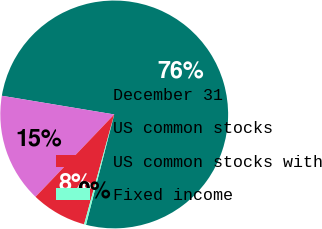Convert chart. <chart><loc_0><loc_0><loc_500><loc_500><pie_chart><fcel>December 31<fcel>US common stocks<fcel>US common stocks with<fcel>Fixed income<nl><fcel>76.37%<fcel>15.49%<fcel>7.88%<fcel>0.27%<nl></chart> 